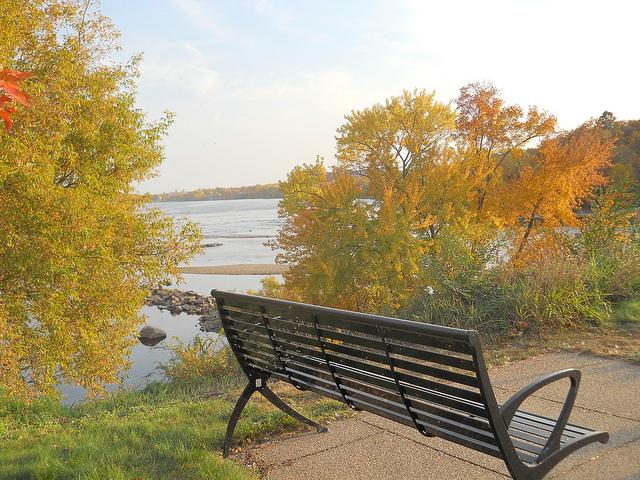Is there a shadow?
Quick response, please. No. Has anyone sat there recently?
Answer briefly. No. What is the furniture made of?
Quick response, please. Metal. What is the color of the bench facing the lake?
Quick response, please. Black. What is the weather like?
Give a very brief answer. Sunny. How many boards are on the bench?
Answer briefly. 20. Does the bench face the water?
Write a very short answer. No. What time of year is it?
Short answer required. Fall. How old is this bench?
Give a very brief answer. New. 